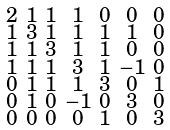Convert formula to latex. <formula><loc_0><loc_0><loc_500><loc_500>\begin{smallmatrix} 2 & 1 & 1 & 1 & 0 & 0 & 0 \\ 1 & 3 & 1 & 1 & 1 & 1 & 0 \\ 1 & 1 & 3 & 1 & 1 & 0 & 0 \\ 1 & 1 & 1 & 3 & 1 & - 1 & 0 \\ 0 & 1 & 1 & 1 & 3 & 0 & 1 \\ 0 & 1 & 0 & - 1 & 0 & 3 & 0 \\ 0 & 0 & 0 & 0 & 1 & 0 & 3 \end{smallmatrix}</formula> 